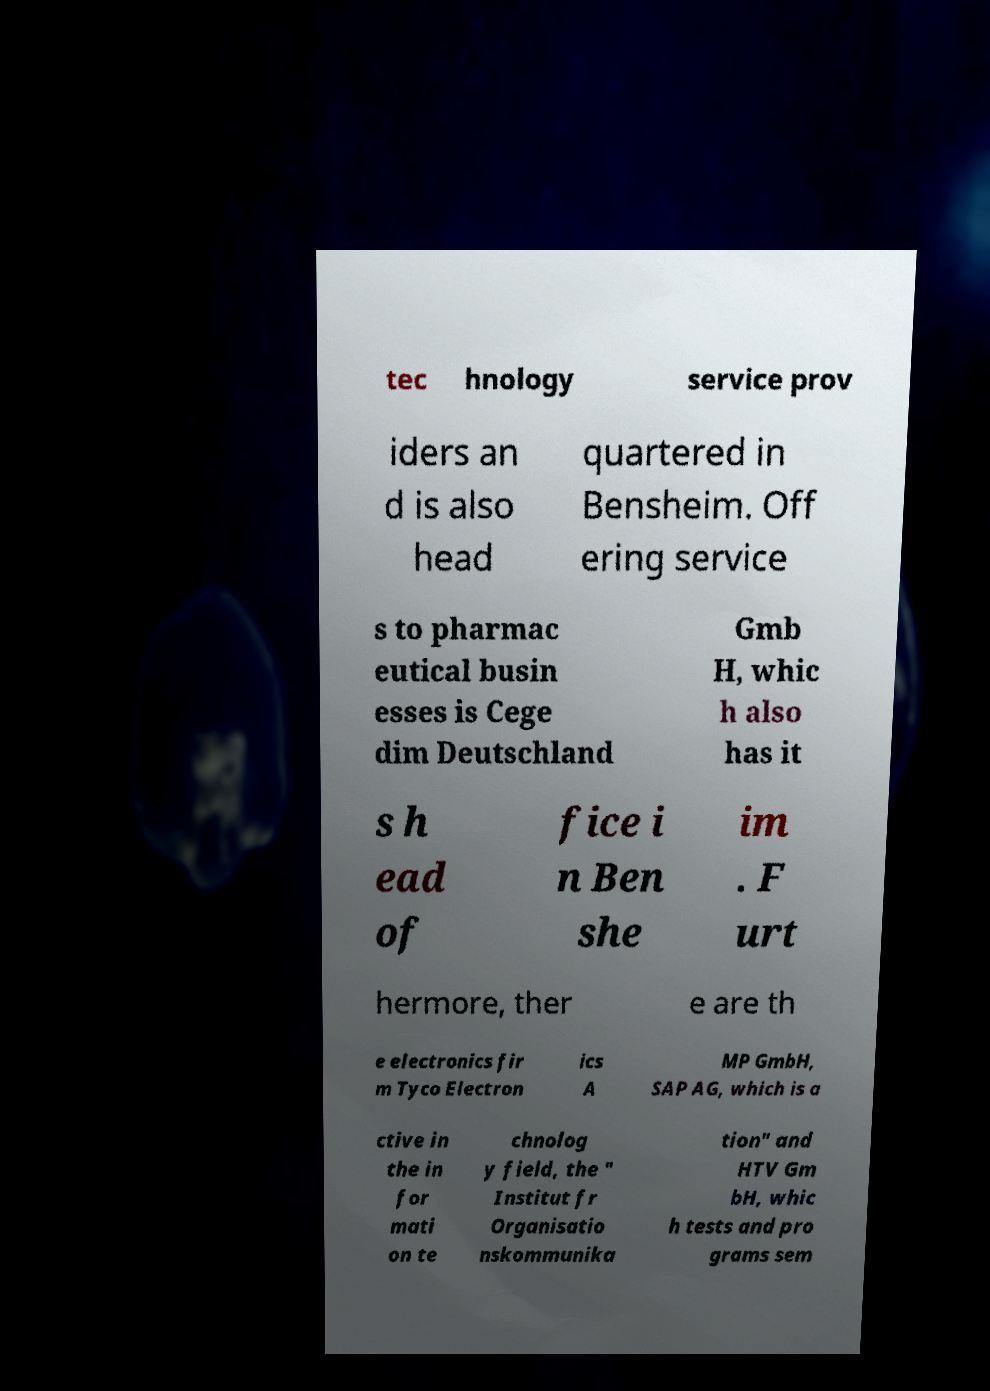Could you extract and type out the text from this image? tec hnology service prov iders an d is also head quartered in Bensheim. Off ering service s to pharmac eutical busin esses is Cege dim Deutschland Gmb H, whic h also has it s h ead of fice i n Ben she im . F urt hermore, ther e are th e electronics fir m Tyco Electron ics A MP GmbH, SAP AG, which is a ctive in the in for mati on te chnolog y field, the " Institut fr Organisatio nskommunika tion" and HTV Gm bH, whic h tests and pro grams sem 